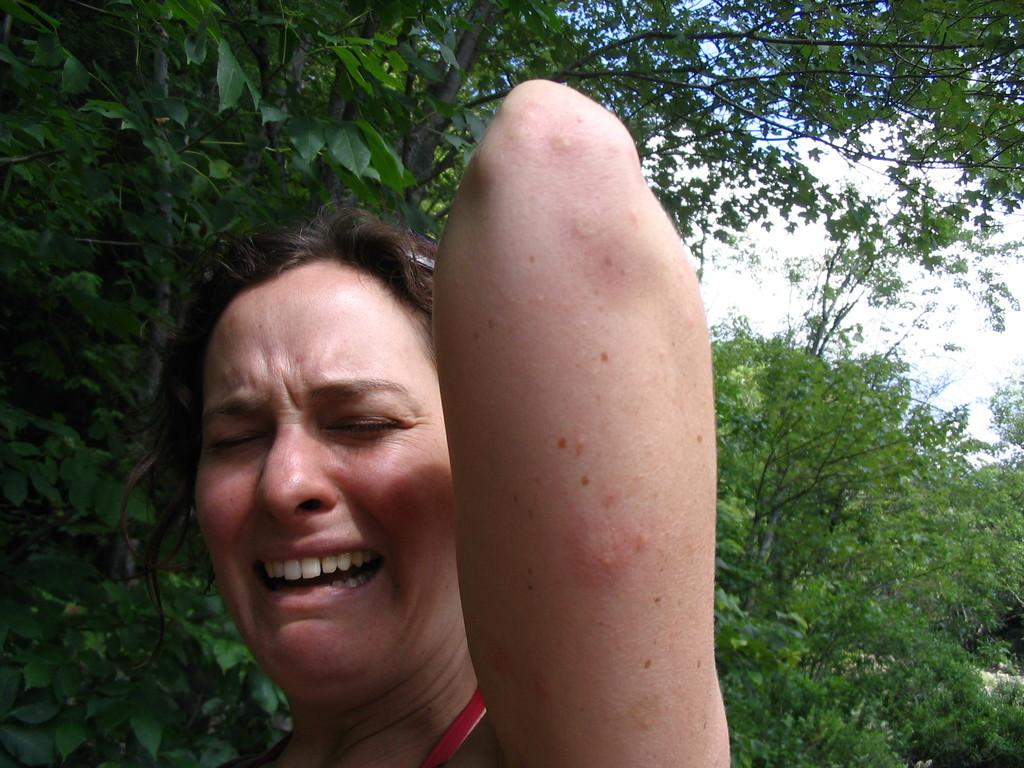Who is the main subject in the picture? There is a woman in the picture. What is the woman doing in the picture? The woman is standing and crying. What can be seen in the background of the picture? There are trees in the background of the picture. What is visible at the top of the picture? The sky is visible at the top of the picture. What type of plant is the cow eating in the image? There is no plant or cow present in the image; it features a woman standing and crying. Can you tell me the credit score of the woman in the image? There is no information about the woman's credit score in the image. 